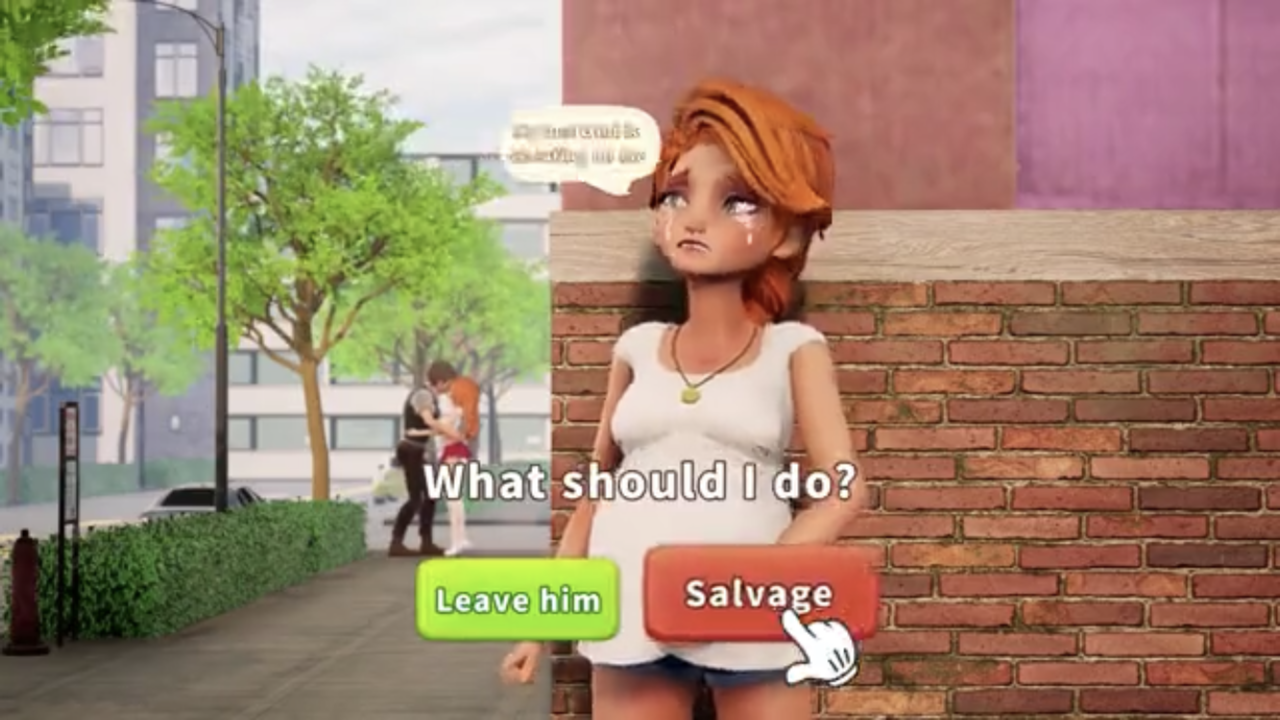Describe the image in detail. Return a comma separated list of succinct tags. Animated image of a human figure, brick wall, tree, buildings, sign post, displayed on a screen with text prompts "What should I do?" with options "Leave him" and "Salvage".

Tags: animated, human figure, brick wall, tree, buildings, sign post, screen, text prompts, decision making. 